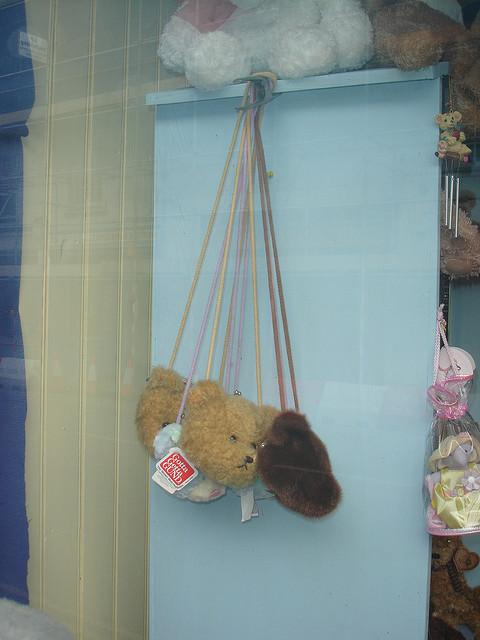What is the bear here doing? Please explain your reasoning. hanging. Strings are used to tie the bear up. the strings are attached to a point that is higher than the bear. 